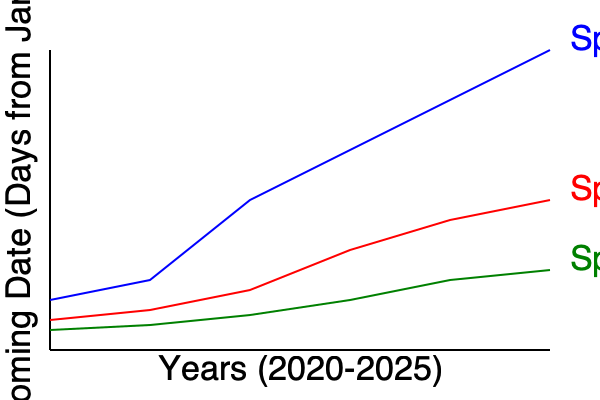Based on the multi-line graph showing the blooming dates of three plant species from 2020 to 2025, which species appears to be most sensitive to the increasing frequency of extreme weather events, and what might this imply about its adaptability to climate change? To answer this question, we need to analyze the trends for each species:

1. Species A (blue line):
   - Shows the steepest decline in blooming date.
   - Blooming date has shifted from around day 300 to day 50 over 5 years.
   - This indicates a significant advancement in blooming time.

2. Species B (red line):
   - Shows a moderate decline in blooming date.
   - Blooming date has shifted from around day 320 to day 200 over 5 years.
   - This indicates a noticeable but less dramatic advancement in blooming time.

3. Species C (green line):
   - Shows the least decline in blooming date.
   - Blooming date has shifted from around day 330 to day 270 over 5 years.
   - This indicates a slight advancement in blooming time.

Species A shows the most dramatic change in blooming date, suggesting it is the most sensitive to environmental changes, likely including extreme weather events. This high sensitivity implies:

1. Greater responsiveness to temperature and other climate-related cues.
2. Potentially higher vulnerability to climate change.
3. Possible mismatches with pollinators or other ecological interactions.
4. Risk of exposure to late frosts or other adverse conditions due to early blooming.

While this sensitivity allows Species A to adapt quickly to changing conditions, it may also put it at greater risk if the rate of change exceeds its ability to cope physiologically or if it becomes desynchronized with other essential ecological factors.
Answer: Species A; high sensitivity may increase vulnerability to rapid climate change. 